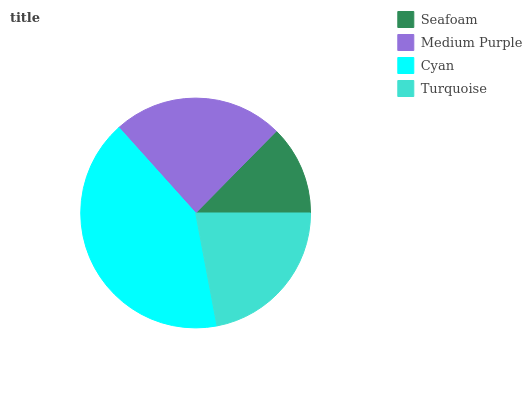Is Seafoam the minimum?
Answer yes or no. Yes. Is Cyan the maximum?
Answer yes or no. Yes. Is Medium Purple the minimum?
Answer yes or no. No. Is Medium Purple the maximum?
Answer yes or no. No. Is Medium Purple greater than Seafoam?
Answer yes or no. Yes. Is Seafoam less than Medium Purple?
Answer yes or no. Yes. Is Seafoam greater than Medium Purple?
Answer yes or no. No. Is Medium Purple less than Seafoam?
Answer yes or no. No. Is Medium Purple the high median?
Answer yes or no. Yes. Is Turquoise the low median?
Answer yes or no. Yes. Is Turquoise the high median?
Answer yes or no. No. Is Seafoam the low median?
Answer yes or no. No. 